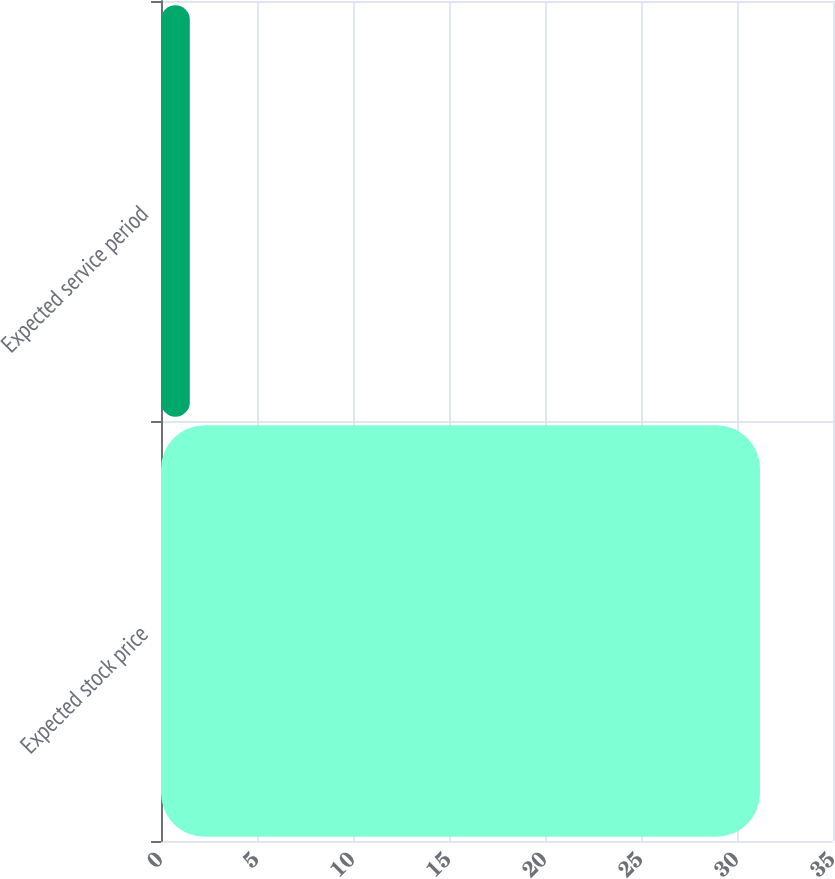Convert chart. <chart><loc_0><loc_0><loc_500><loc_500><bar_chart><fcel>Expected stock price<fcel>Expected service period<nl><fcel>31.2<fcel>1.5<nl></chart> 